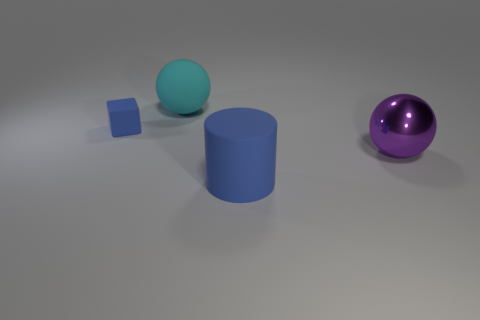Are there any other things that have the same size as the cube?
Offer a terse response. No. Is there any other thing of the same color as the big rubber ball?
Give a very brief answer. No. The thing that is the same color as the large rubber cylinder is what shape?
Your answer should be compact. Cube. Is the blue thing that is on the left side of the rubber ball made of the same material as the large thing right of the large blue matte thing?
Make the answer very short. No. Is there anything else that has the same shape as the big blue object?
Your answer should be compact. No. What color is the rubber ball?
Keep it short and to the point. Cyan. What number of other things are the same shape as the purple thing?
Keep it short and to the point. 1. There is a rubber cylinder that is the same size as the purple ball; what color is it?
Offer a very short reply. Blue. Is there a small brown rubber cylinder?
Your response must be concise. No. There is a large rubber thing in front of the big cyan matte thing; what shape is it?
Keep it short and to the point. Cylinder. 